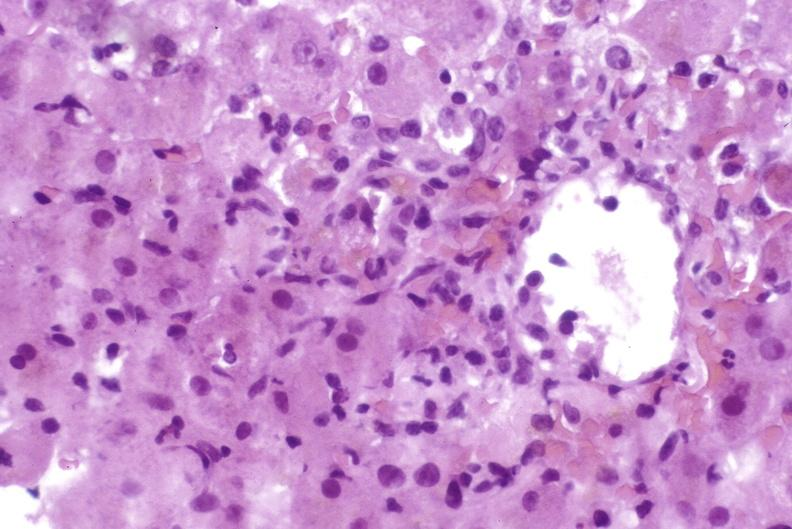s lesion of myocytolysis present?
Answer the question using a single word or phrase. No 